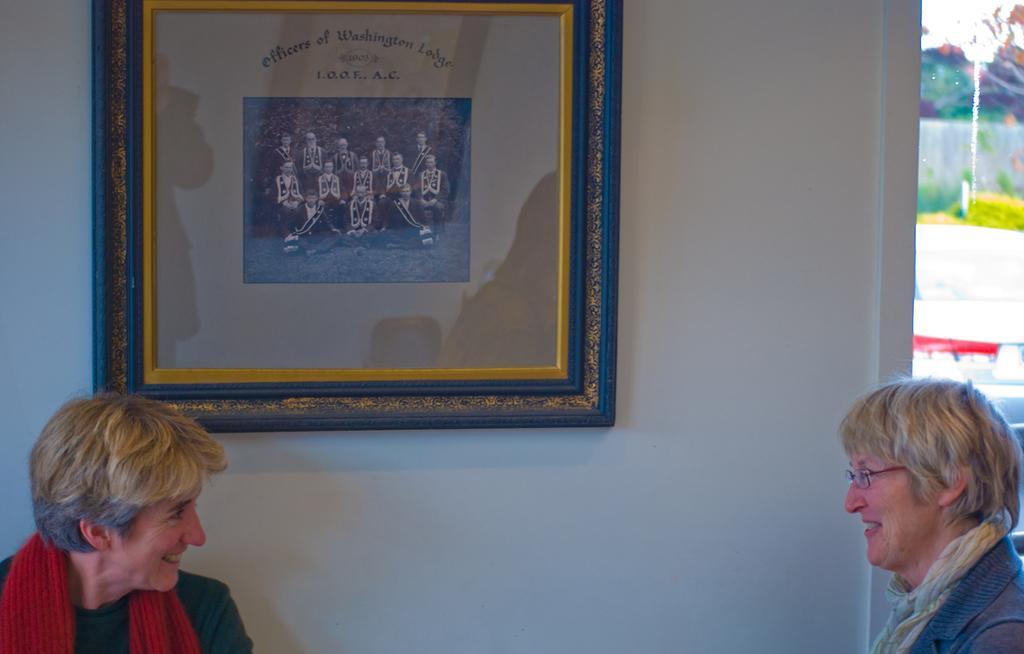In one or two sentences, can you explain what this image depicts? This is the picture of a room. In this image there are two persons smiling. There is a frame on the wall and there is a picture of a group of people and there is a text on the frame. On the right side of the image there are trees behind the window and there is sky. 